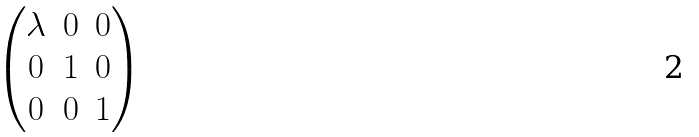Convert formula to latex. <formula><loc_0><loc_0><loc_500><loc_500>\begin{pmatrix} { \lambda } & 0 & 0 \\ 0 & 1 & 0 \\ 0 & 0 & 1 \end{pmatrix}</formula> 